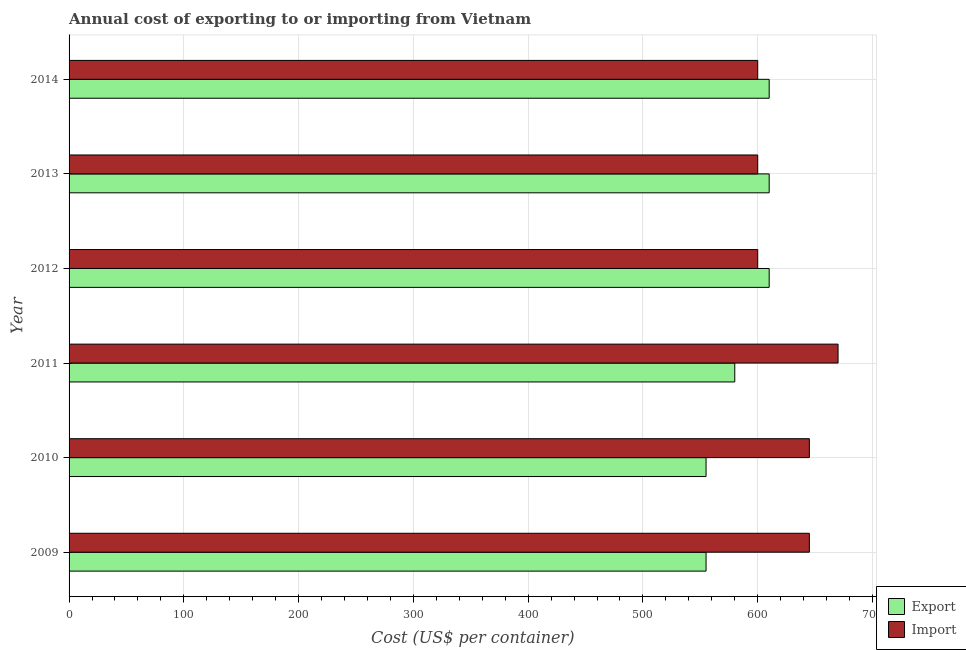How many bars are there on the 5th tick from the top?
Give a very brief answer. 2. What is the label of the 5th group of bars from the top?
Give a very brief answer. 2010. What is the export cost in 2011?
Your answer should be very brief. 580. Across all years, what is the maximum import cost?
Make the answer very short. 670. Across all years, what is the minimum export cost?
Your answer should be very brief. 555. In which year was the export cost maximum?
Provide a succinct answer. 2012. In which year was the import cost minimum?
Keep it short and to the point. 2012. What is the total export cost in the graph?
Your answer should be compact. 3520. What is the difference between the import cost in 2011 and that in 2014?
Offer a terse response. 70. What is the difference between the import cost in 2011 and the export cost in 2010?
Keep it short and to the point. 115. What is the average import cost per year?
Your answer should be compact. 626.67. In the year 2012, what is the difference between the export cost and import cost?
Your answer should be compact. 10. In how many years, is the export cost greater than 460 US$?
Make the answer very short. 6. What is the ratio of the import cost in 2009 to that in 2010?
Your answer should be very brief. 1. Is the difference between the export cost in 2009 and 2012 greater than the difference between the import cost in 2009 and 2012?
Provide a short and direct response. No. What is the difference between the highest and the second highest import cost?
Offer a very short reply. 25. What is the difference between the highest and the lowest export cost?
Make the answer very short. 55. In how many years, is the export cost greater than the average export cost taken over all years?
Ensure brevity in your answer.  3. What does the 1st bar from the top in 2013 represents?
Keep it short and to the point. Import. What does the 1st bar from the bottom in 2009 represents?
Make the answer very short. Export. How many bars are there?
Offer a very short reply. 12. How many years are there in the graph?
Make the answer very short. 6. What is the difference between two consecutive major ticks on the X-axis?
Offer a very short reply. 100. Are the values on the major ticks of X-axis written in scientific E-notation?
Make the answer very short. No. Does the graph contain any zero values?
Provide a succinct answer. No. Does the graph contain grids?
Provide a succinct answer. Yes. How many legend labels are there?
Make the answer very short. 2. How are the legend labels stacked?
Give a very brief answer. Vertical. What is the title of the graph?
Provide a short and direct response. Annual cost of exporting to or importing from Vietnam. Does "Frequency of shipment arrival" appear as one of the legend labels in the graph?
Provide a succinct answer. No. What is the label or title of the X-axis?
Your response must be concise. Cost (US$ per container). What is the Cost (US$ per container) of Export in 2009?
Your answer should be very brief. 555. What is the Cost (US$ per container) of Import in 2009?
Offer a very short reply. 645. What is the Cost (US$ per container) in Export in 2010?
Provide a succinct answer. 555. What is the Cost (US$ per container) of Import in 2010?
Give a very brief answer. 645. What is the Cost (US$ per container) of Export in 2011?
Offer a very short reply. 580. What is the Cost (US$ per container) in Import in 2011?
Offer a very short reply. 670. What is the Cost (US$ per container) in Export in 2012?
Your answer should be very brief. 610. What is the Cost (US$ per container) in Import in 2012?
Offer a very short reply. 600. What is the Cost (US$ per container) in Export in 2013?
Provide a short and direct response. 610. What is the Cost (US$ per container) of Import in 2013?
Your answer should be very brief. 600. What is the Cost (US$ per container) in Export in 2014?
Make the answer very short. 610. What is the Cost (US$ per container) of Import in 2014?
Make the answer very short. 600. Across all years, what is the maximum Cost (US$ per container) in Export?
Offer a very short reply. 610. Across all years, what is the maximum Cost (US$ per container) in Import?
Keep it short and to the point. 670. Across all years, what is the minimum Cost (US$ per container) of Export?
Keep it short and to the point. 555. Across all years, what is the minimum Cost (US$ per container) of Import?
Provide a succinct answer. 600. What is the total Cost (US$ per container) of Export in the graph?
Your answer should be very brief. 3520. What is the total Cost (US$ per container) in Import in the graph?
Ensure brevity in your answer.  3760. What is the difference between the Cost (US$ per container) in Export in 2009 and that in 2010?
Your answer should be compact. 0. What is the difference between the Cost (US$ per container) in Import in 2009 and that in 2010?
Provide a succinct answer. 0. What is the difference between the Cost (US$ per container) of Import in 2009 and that in 2011?
Make the answer very short. -25. What is the difference between the Cost (US$ per container) in Export in 2009 and that in 2012?
Your response must be concise. -55. What is the difference between the Cost (US$ per container) of Import in 2009 and that in 2012?
Your response must be concise. 45. What is the difference between the Cost (US$ per container) in Export in 2009 and that in 2013?
Offer a terse response. -55. What is the difference between the Cost (US$ per container) of Export in 2009 and that in 2014?
Provide a short and direct response. -55. What is the difference between the Cost (US$ per container) in Import in 2010 and that in 2011?
Offer a terse response. -25. What is the difference between the Cost (US$ per container) in Export in 2010 and that in 2012?
Ensure brevity in your answer.  -55. What is the difference between the Cost (US$ per container) in Import in 2010 and that in 2012?
Your answer should be very brief. 45. What is the difference between the Cost (US$ per container) in Export in 2010 and that in 2013?
Your answer should be compact. -55. What is the difference between the Cost (US$ per container) of Import in 2010 and that in 2013?
Make the answer very short. 45. What is the difference between the Cost (US$ per container) of Export in 2010 and that in 2014?
Ensure brevity in your answer.  -55. What is the difference between the Cost (US$ per container) in Export in 2011 and that in 2012?
Your answer should be compact. -30. What is the difference between the Cost (US$ per container) of Import in 2011 and that in 2014?
Give a very brief answer. 70. What is the difference between the Cost (US$ per container) of Export in 2012 and that in 2013?
Give a very brief answer. 0. What is the difference between the Cost (US$ per container) of Import in 2012 and that in 2014?
Keep it short and to the point. 0. What is the difference between the Cost (US$ per container) in Export in 2013 and that in 2014?
Ensure brevity in your answer.  0. What is the difference between the Cost (US$ per container) in Export in 2009 and the Cost (US$ per container) in Import in 2010?
Offer a very short reply. -90. What is the difference between the Cost (US$ per container) in Export in 2009 and the Cost (US$ per container) in Import in 2011?
Give a very brief answer. -115. What is the difference between the Cost (US$ per container) of Export in 2009 and the Cost (US$ per container) of Import in 2012?
Provide a succinct answer. -45. What is the difference between the Cost (US$ per container) of Export in 2009 and the Cost (US$ per container) of Import in 2013?
Your answer should be very brief. -45. What is the difference between the Cost (US$ per container) of Export in 2009 and the Cost (US$ per container) of Import in 2014?
Your response must be concise. -45. What is the difference between the Cost (US$ per container) of Export in 2010 and the Cost (US$ per container) of Import in 2011?
Offer a very short reply. -115. What is the difference between the Cost (US$ per container) of Export in 2010 and the Cost (US$ per container) of Import in 2012?
Make the answer very short. -45. What is the difference between the Cost (US$ per container) of Export in 2010 and the Cost (US$ per container) of Import in 2013?
Give a very brief answer. -45. What is the difference between the Cost (US$ per container) in Export in 2010 and the Cost (US$ per container) in Import in 2014?
Offer a terse response. -45. What is the difference between the Cost (US$ per container) in Export in 2011 and the Cost (US$ per container) in Import in 2013?
Offer a terse response. -20. What is the difference between the Cost (US$ per container) of Export in 2011 and the Cost (US$ per container) of Import in 2014?
Offer a very short reply. -20. What is the difference between the Cost (US$ per container) of Export in 2012 and the Cost (US$ per container) of Import in 2013?
Your answer should be very brief. 10. What is the difference between the Cost (US$ per container) of Export in 2012 and the Cost (US$ per container) of Import in 2014?
Your answer should be very brief. 10. What is the difference between the Cost (US$ per container) of Export in 2013 and the Cost (US$ per container) of Import in 2014?
Make the answer very short. 10. What is the average Cost (US$ per container) of Export per year?
Your response must be concise. 586.67. What is the average Cost (US$ per container) in Import per year?
Give a very brief answer. 626.67. In the year 2009, what is the difference between the Cost (US$ per container) of Export and Cost (US$ per container) of Import?
Your answer should be compact. -90. In the year 2010, what is the difference between the Cost (US$ per container) in Export and Cost (US$ per container) in Import?
Offer a terse response. -90. In the year 2011, what is the difference between the Cost (US$ per container) of Export and Cost (US$ per container) of Import?
Your answer should be compact. -90. In the year 2012, what is the difference between the Cost (US$ per container) in Export and Cost (US$ per container) in Import?
Offer a terse response. 10. What is the ratio of the Cost (US$ per container) of Import in 2009 to that in 2010?
Keep it short and to the point. 1. What is the ratio of the Cost (US$ per container) of Export in 2009 to that in 2011?
Ensure brevity in your answer.  0.96. What is the ratio of the Cost (US$ per container) in Import in 2009 to that in 2011?
Make the answer very short. 0.96. What is the ratio of the Cost (US$ per container) in Export in 2009 to that in 2012?
Provide a short and direct response. 0.91. What is the ratio of the Cost (US$ per container) in Import in 2009 to that in 2012?
Provide a short and direct response. 1.07. What is the ratio of the Cost (US$ per container) in Export in 2009 to that in 2013?
Provide a succinct answer. 0.91. What is the ratio of the Cost (US$ per container) of Import in 2009 to that in 2013?
Provide a short and direct response. 1.07. What is the ratio of the Cost (US$ per container) in Export in 2009 to that in 2014?
Provide a succinct answer. 0.91. What is the ratio of the Cost (US$ per container) in Import in 2009 to that in 2014?
Offer a very short reply. 1.07. What is the ratio of the Cost (US$ per container) of Export in 2010 to that in 2011?
Offer a terse response. 0.96. What is the ratio of the Cost (US$ per container) in Import in 2010 to that in 2011?
Give a very brief answer. 0.96. What is the ratio of the Cost (US$ per container) of Export in 2010 to that in 2012?
Keep it short and to the point. 0.91. What is the ratio of the Cost (US$ per container) of Import in 2010 to that in 2012?
Keep it short and to the point. 1.07. What is the ratio of the Cost (US$ per container) of Export in 2010 to that in 2013?
Offer a very short reply. 0.91. What is the ratio of the Cost (US$ per container) in Import in 2010 to that in 2013?
Make the answer very short. 1.07. What is the ratio of the Cost (US$ per container) of Export in 2010 to that in 2014?
Your answer should be very brief. 0.91. What is the ratio of the Cost (US$ per container) in Import in 2010 to that in 2014?
Offer a terse response. 1.07. What is the ratio of the Cost (US$ per container) in Export in 2011 to that in 2012?
Provide a short and direct response. 0.95. What is the ratio of the Cost (US$ per container) of Import in 2011 to that in 2012?
Ensure brevity in your answer.  1.12. What is the ratio of the Cost (US$ per container) of Export in 2011 to that in 2013?
Your answer should be very brief. 0.95. What is the ratio of the Cost (US$ per container) of Import in 2011 to that in 2013?
Offer a very short reply. 1.12. What is the ratio of the Cost (US$ per container) of Export in 2011 to that in 2014?
Your answer should be compact. 0.95. What is the ratio of the Cost (US$ per container) of Import in 2011 to that in 2014?
Give a very brief answer. 1.12. What is the ratio of the Cost (US$ per container) of Export in 2012 to that in 2013?
Your answer should be very brief. 1. What is the ratio of the Cost (US$ per container) in Import in 2012 to that in 2013?
Provide a short and direct response. 1. What is the ratio of the Cost (US$ per container) in Export in 2012 to that in 2014?
Your answer should be compact. 1. What is the ratio of the Cost (US$ per container) of Import in 2012 to that in 2014?
Your response must be concise. 1. What is the difference between the highest and the second highest Cost (US$ per container) of Export?
Give a very brief answer. 0. What is the difference between the highest and the second highest Cost (US$ per container) in Import?
Provide a succinct answer. 25. What is the difference between the highest and the lowest Cost (US$ per container) in Import?
Give a very brief answer. 70. 